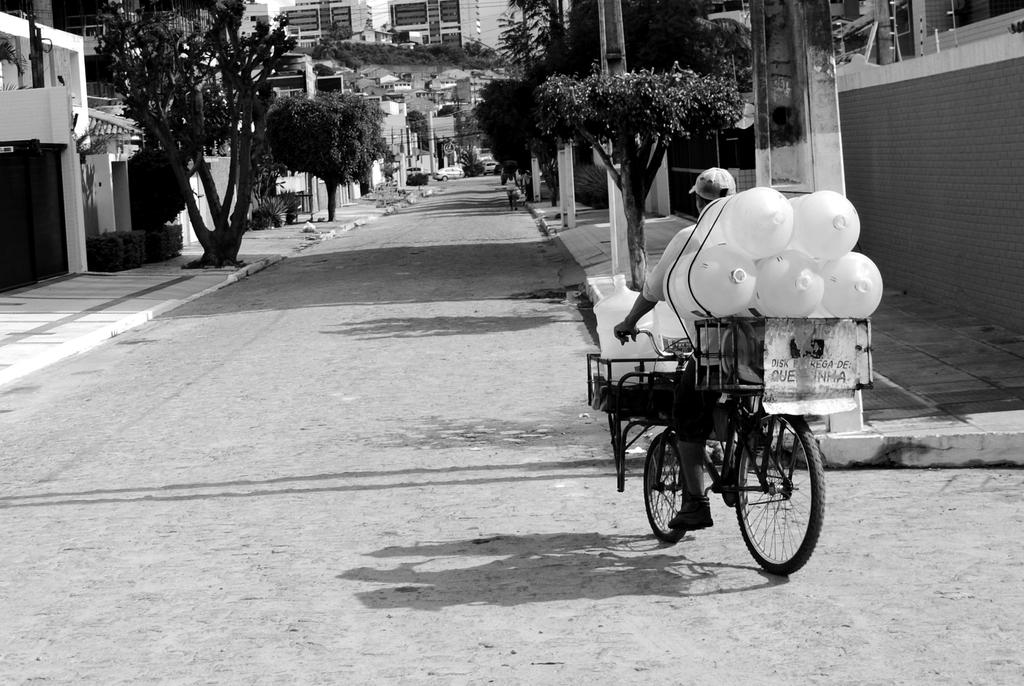What is on the bicycle in the image? There are cans on the bicycle in the image. Who is riding the bicycle? A man is riding the bicycle in the image. Where is the bicycle located? The bicycle is on a road in the image. What else can be seen in the image? There are buildings, cars, and trees visible in the image. How does the man's haircut change throughout the image? There is no information about the man's haircut in the image, so it cannot be determined if it changes or not. 